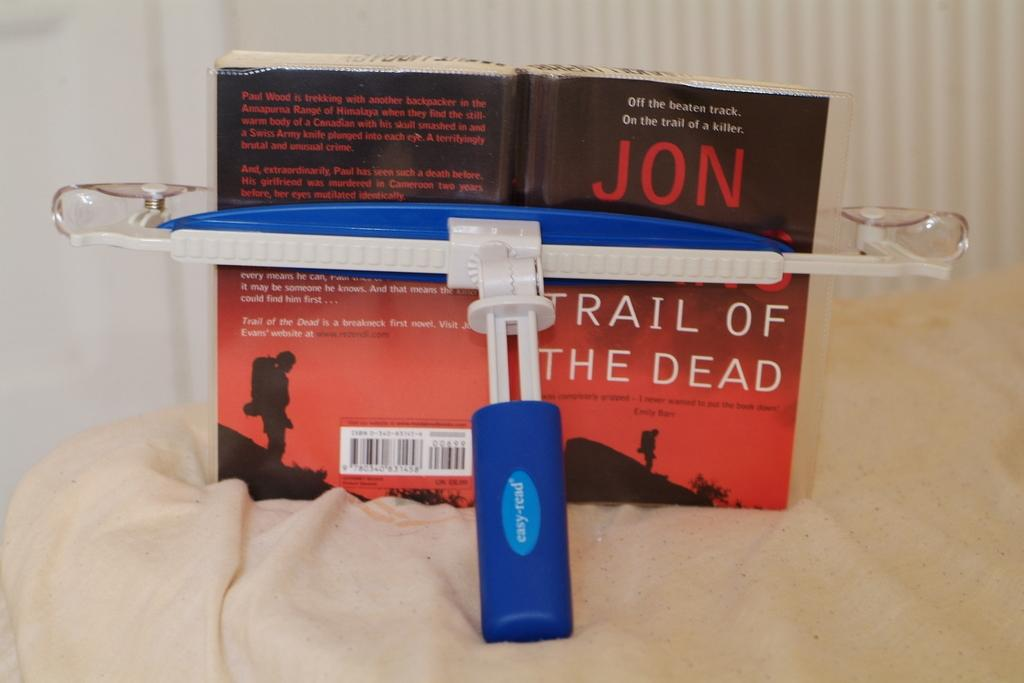<image>
Provide a brief description of the given image. a book that is called Trail of the Dead 